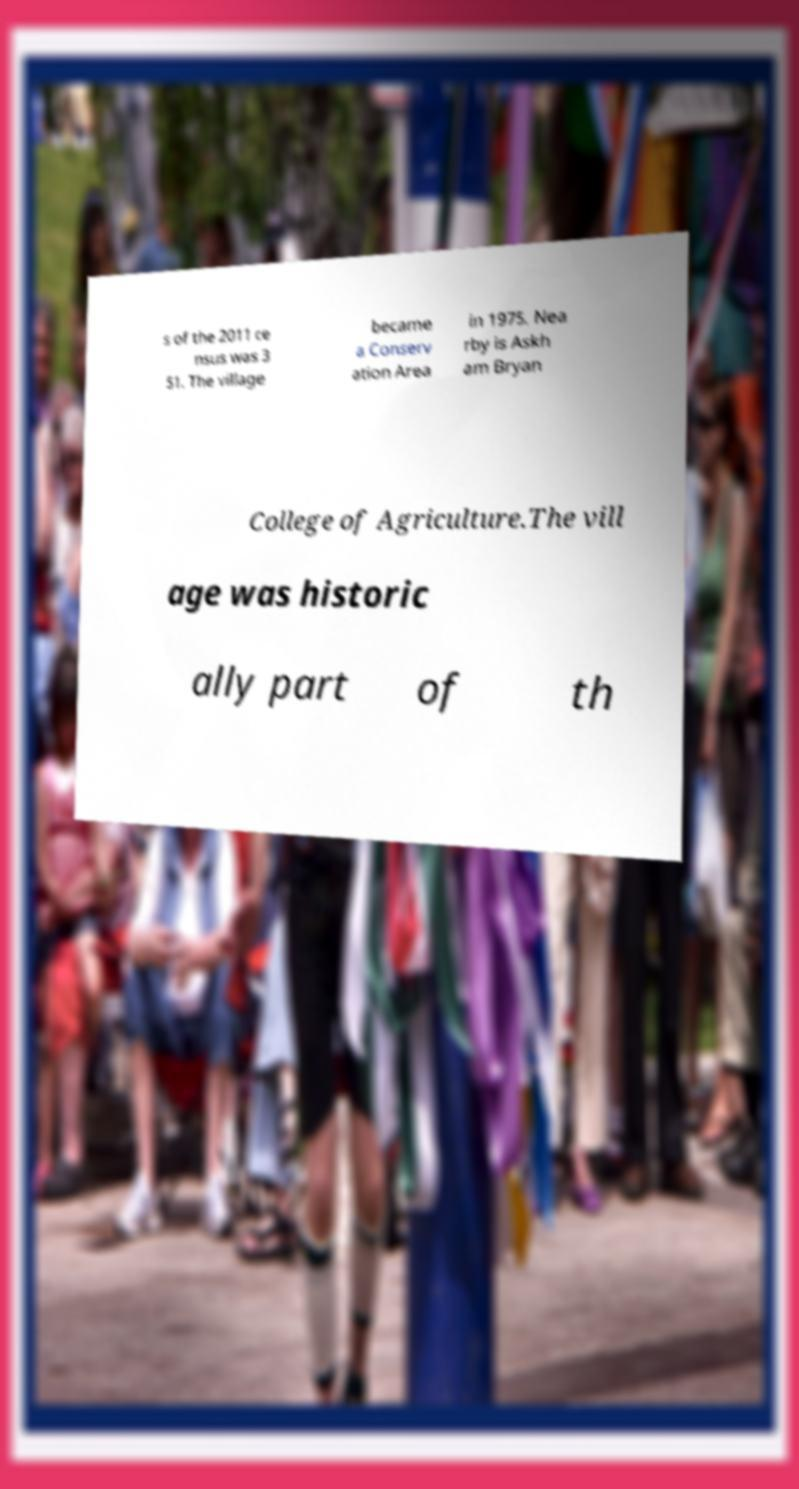Please identify and transcribe the text found in this image. s of the 2011 ce nsus was 3 51. The village became a Conserv ation Area in 1975. Nea rby is Askh am Bryan College of Agriculture.The vill age was historic ally part of th 